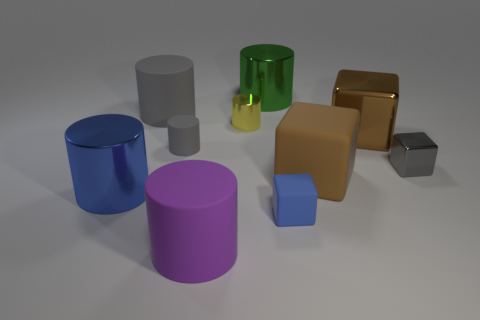Subtract all green cylinders. How many cylinders are left? 5 Subtract all tiny yellow shiny cylinders. How many cylinders are left? 5 Subtract 3 cylinders. How many cylinders are left? 3 Subtract all blue cylinders. Subtract all gray cubes. How many cylinders are left? 5 Subtract all cylinders. How many objects are left? 4 Subtract all yellow rubber cubes. Subtract all blocks. How many objects are left? 6 Add 9 yellow things. How many yellow things are left? 10 Add 3 big brown rubber blocks. How many big brown rubber blocks exist? 4 Subtract 2 gray cylinders. How many objects are left? 8 